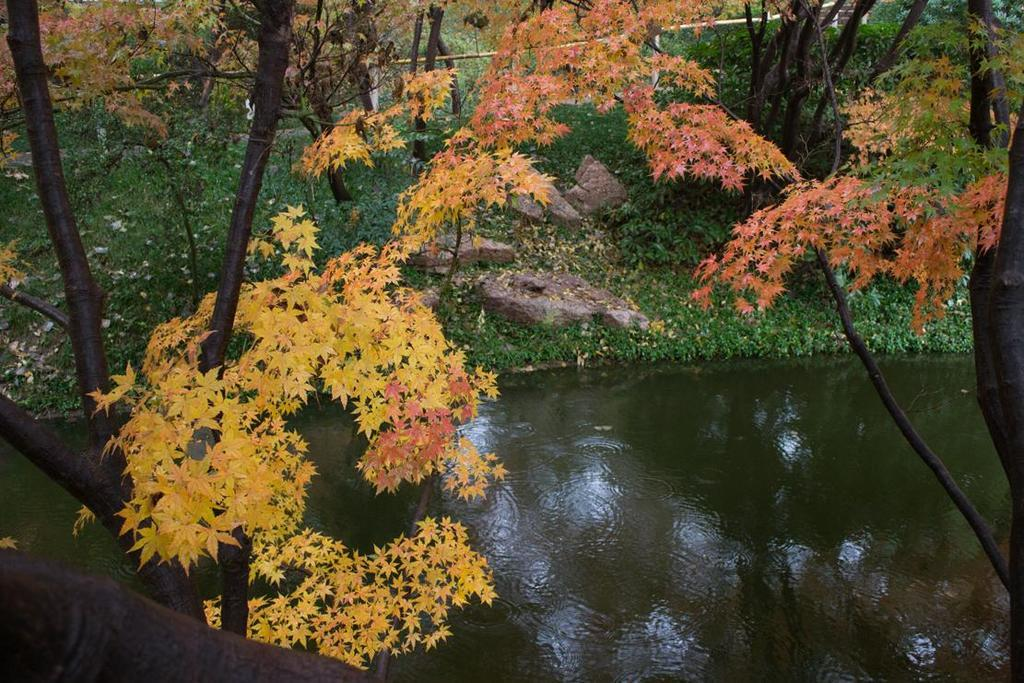What type of vegetation can be seen in the image? There are trees in the image. What is the ground covered with in the image? There is grass in the image. What natural element is visible in the image? There is water visible in the image. What type of material is present in the image? There are stones in the image. What structure can be seen in the image? There is a wall in the image. What type of prison can be seen in the image? There is no prison present in the image; it features trees, grass, water, stones, and a wall. What type of voyage is depicted in the image? There is no voyage depicted in the image; it shows a natural scene with trees, grass, water, stones, and a wall. 